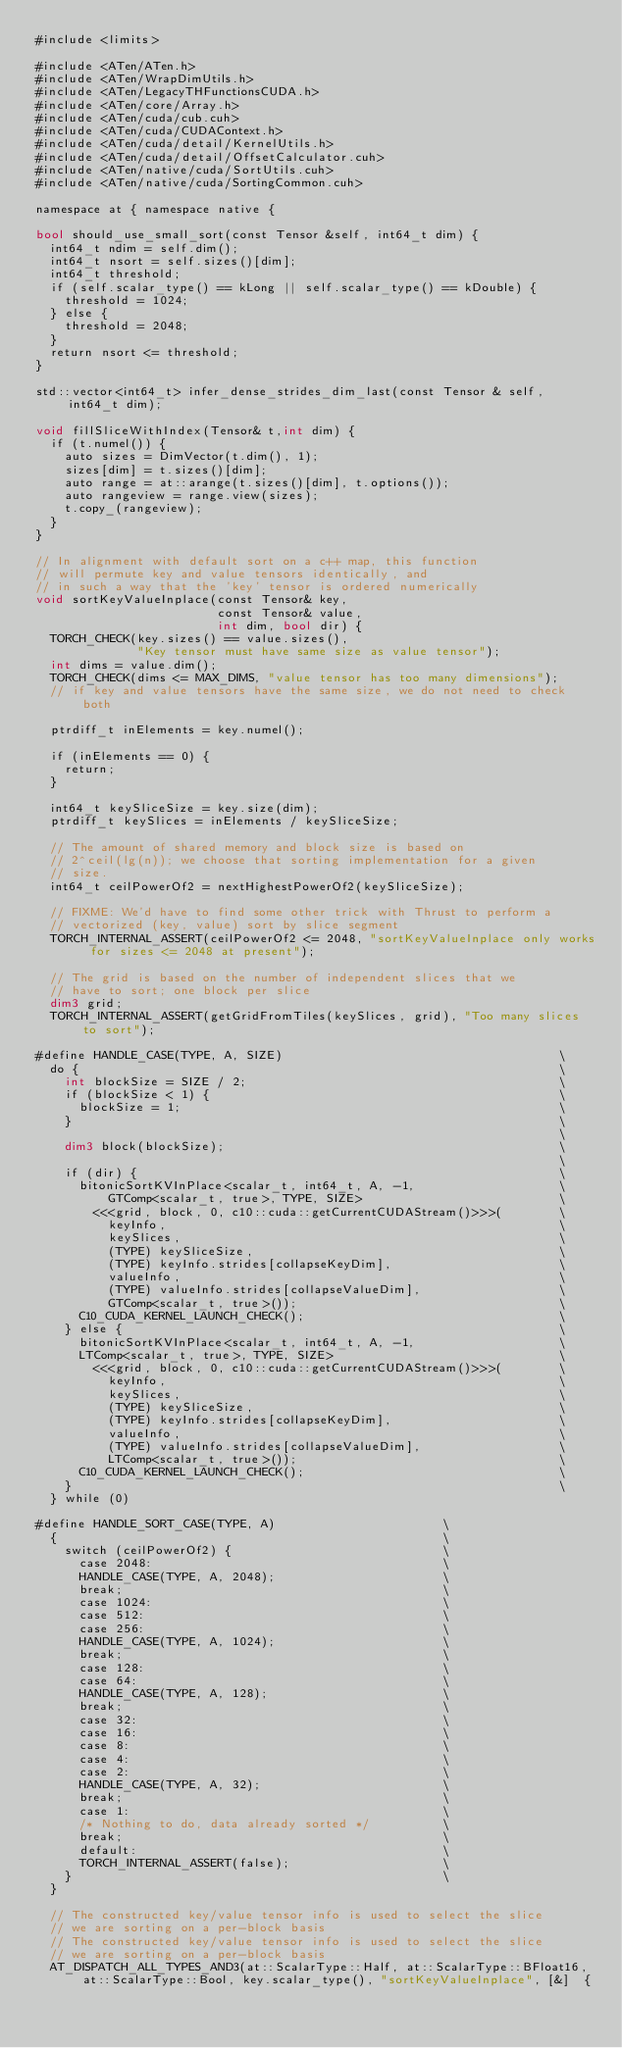Convert code to text. <code><loc_0><loc_0><loc_500><loc_500><_Cuda_>#include <limits>

#include <ATen/ATen.h>
#include <ATen/WrapDimUtils.h>
#include <ATen/LegacyTHFunctionsCUDA.h>
#include <ATen/core/Array.h>
#include <ATen/cuda/cub.cuh>
#include <ATen/cuda/CUDAContext.h>
#include <ATen/cuda/detail/KernelUtils.h>
#include <ATen/cuda/detail/OffsetCalculator.cuh>
#include <ATen/native/cuda/SortUtils.cuh>
#include <ATen/native/cuda/SortingCommon.cuh>

namespace at { namespace native {

bool should_use_small_sort(const Tensor &self, int64_t dim) {
  int64_t ndim = self.dim();
  int64_t nsort = self.sizes()[dim];
  int64_t threshold;
  if (self.scalar_type() == kLong || self.scalar_type() == kDouble) {
    threshold = 1024;
  } else {
    threshold = 2048;
  }
  return nsort <= threshold;
}

std::vector<int64_t> infer_dense_strides_dim_last(const Tensor & self, int64_t dim);

void fillSliceWithIndex(Tensor& t,int dim) {
  if (t.numel()) {
    auto sizes = DimVector(t.dim(), 1);
    sizes[dim] = t.sizes()[dim];
    auto range = at::arange(t.sizes()[dim], t.options());
    auto rangeview = range.view(sizes);
    t.copy_(rangeview);
  }
}

// In alignment with default sort on a c++ map, this function
// will permute key and value tensors identically, and
// in such a way that the 'key' tensor is ordered numerically
void sortKeyValueInplace(const Tensor& key,
                         const Tensor& value,
                         int dim, bool dir) {
  TORCH_CHECK(key.sizes() == value.sizes(),
              "Key tensor must have same size as value tensor");
  int dims = value.dim();
  TORCH_CHECK(dims <= MAX_DIMS, "value tensor has too many dimensions");
  // if key and value tensors have the same size, we do not need to check both

  ptrdiff_t inElements = key.numel();

  if (inElements == 0) {
    return;
  }

  int64_t keySliceSize = key.size(dim);
  ptrdiff_t keySlices = inElements / keySliceSize;

  // The amount of shared memory and block size is based on
  // 2^ceil(lg(n)); we choose that sorting implementation for a given
  // size.
  int64_t ceilPowerOf2 = nextHighestPowerOf2(keySliceSize);

  // FIXME: We'd have to find some other trick with Thrust to perform a
  // vectorized (key, value) sort by slice segment
  TORCH_INTERNAL_ASSERT(ceilPowerOf2 <= 2048, "sortKeyValueInplace only works for sizes <= 2048 at present");

  // The grid is based on the number of independent slices that we
  // have to sort; one block per slice
  dim3 grid;
  TORCH_INTERNAL_ASSERT(getGridFromTiles(keySlices, grid), "Too many slices to sort");

#define HANDLE_CASE(TYPE, A, SIZE)                                      \
  do {                                                                  \
    int blockSize = SIZE / 2;                                           \
    if (blockSize < 1) {                                                \
      blockSize = 1;                                                    \
    }                                                                   \
                                                                        \
    dim3 block(blockSize);                                              \
                                                                        \
    if (dir) {                                                          \
      bitonicSortKVInPlace<scalar_t, int64_t, A, -1,                    \
          GTComp<scalar_t, true>, TYPE, SIZE>                           \
        <<<grid, block, 0, c10::cuda::getCurrentCUDAStream()>>>(        \
          keyInfo,                                                      \
          keySlices,                                                    \
          (TYPE) keySliceSize,                                          \
          (TYPE) keyInfo.strides[collapseKeyDim],                       \
          valueInfo,                                                    \
          (TYPE) valueInfo.strides[collapseValueDim],                   \
          GTComp<scalar_t, true>());                                    \
      C10_CUDA_KERNEL_LAUNCH_CHECK();                                   \
    } else {                                                            \
      bitonicSortKVInPlace<scalar_t, int64_t, A, -1,                    \
      LTComp<scalar_t, true>, TYPE, SIZE>                               \
        <<<grid, block, 0, c10::cuda::getCurrentCUDAStream()>>>(        \
          keyInfo,                                                      \
          keySlices,                                                    \
          (TYPE) keySliceSize,                                          \
          (TYPE) keyInfo.strides[collapseKeyDim],                       \
          valueInfo,                                                    \
          (TYPE) valueInfo.strides[collapseValueDim],                   \
          LTComp<scalar_t, true>());                                    \
      C10_CUDA_KERNEL_LAUNCH_CHECK();                                   \
    }                                                                   \
  } while (0)

#define HANDLE_SORT_CASE(TYPE, A)                       \
  {                                                     \
    switch (ceilPowerOf2) {                             \
      case 2048:                                        \
      HANDLE_CASE(TYPE, A, 2048);                       \
      break;                                            \
      case 1024:                                        \
      case 512:                                         \
      case 256:                                         \
      HANDLE_CASE(TYPE, A, 1024);                       \
      break;                                            \
      case 128:                                         \
      case 64:                                          \
      HANDLE_CASE(TYPE, A, 128);                        \
      break;                                            \
      case 32:                                          \
      case 16:                                          \
      case 8:                                           \
      case 4:                                           \
      case 2:                                           \
      HANDLE_CASE(TYPE, A, 32);                         \
      break;                                            \
      case 1:                                           \
      /* Nothing to do, data already sorted */          \
      break;                                            \
      default:                                          \
      TORCH_INTERNAL_ASSERT(false);                     \
    }                                                   \
  }

  // The constructed key/value tensor info is used to select the slice
  // we are sorting on a per-block basis
  // The constructed key/value tensor info is used to select the slice
  // we are sorting on a per-block basis
  AT_DISPATCH_ALL_TYPES_AND3(at::ScalarType::Half, at::ScalarType::BFloat16, at::ScalarType::Bool, key.scalar_type(), "sortKeyValueInplace", [&]  {</code> 